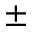<formula> <loc_0><loc_0><loc_500><loc_500>\pm</formula> 